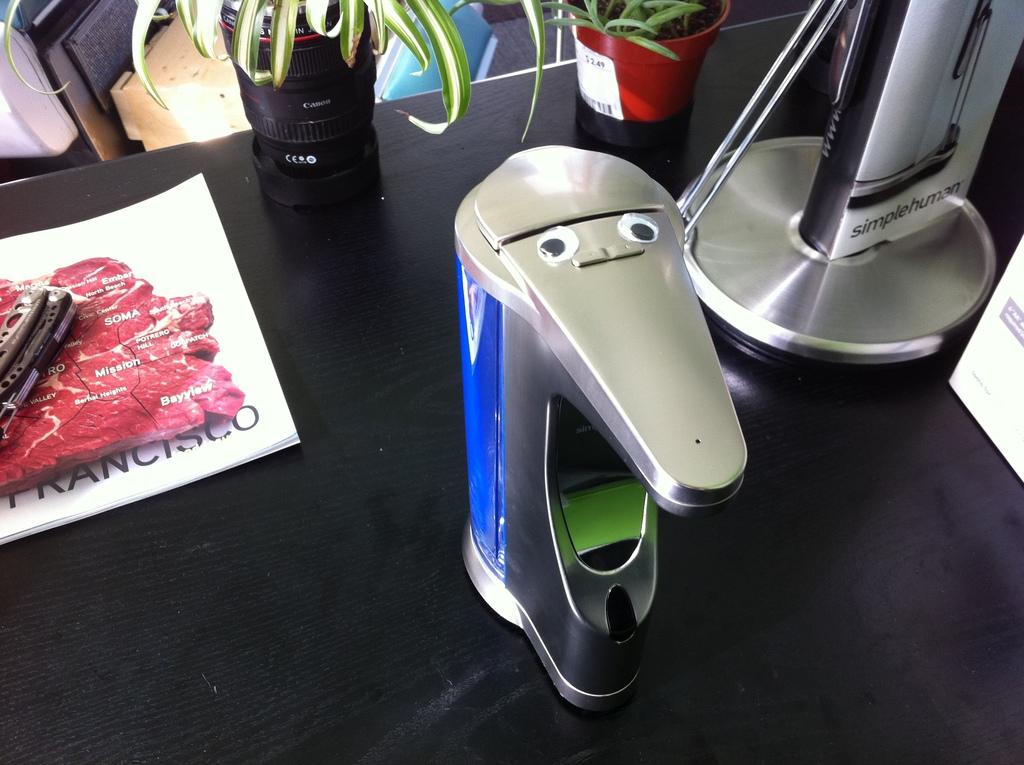Does this look like a face to you?
Give a very brief answer. Answering does not require reading text in the image. What place does the paper say?
Ensure brevity in your answer.  Francisco. 